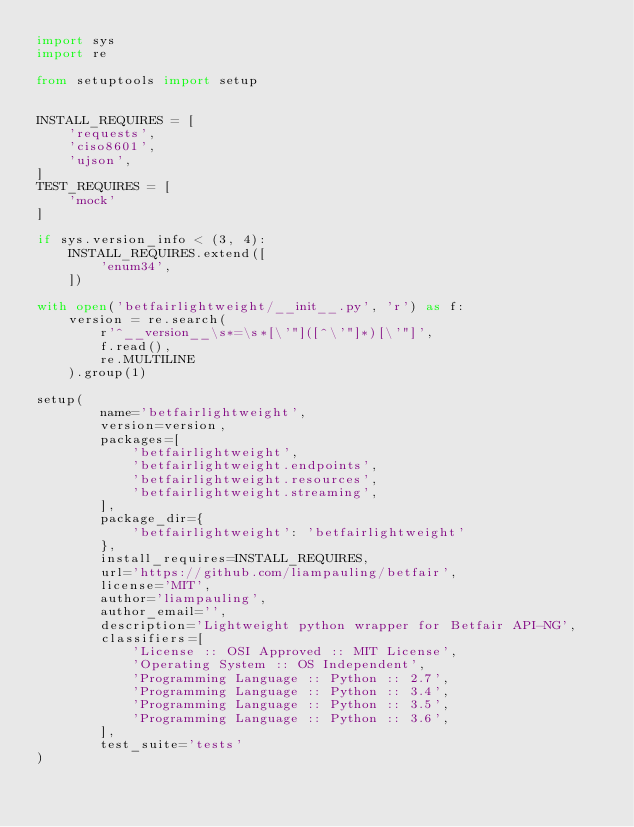Convert code to text. <code><loc_0><loc_0><loc_500><loc_500><_Python_>import sys
import re

from setuptools import setup


INSTALL_REQUIRES = [
    'requests',
    'ciso8601',
    'ujson',
]
TEST_REQUIRES = [
    'mock'
]

if sys.version_info < (3, 4):
    INSTALL_REQUIRES.extend([
        'enum34',
    ])

with open('betfairlightweight/__init__.py', 'r') as f:
    version = re.search(
        r'^__version__\s*=\s*[\'"]([^\'"]*)[\'"]',
        f.read(),
        re.MULTILINE
    ).group(1)

setup(
        name='betfairlightweight',
        version=version,
        packages=[
            'betfairlightweight',
            'betfairlightweight.endpoints',
            'betfairlightweight.resources',
            'betfairlightweight.streaming',
        ],
        package_dir={
            'betfairlightweight': 'betfairlightweight'
        },
        install_requires=INSTALL_REQUIRES,
        url='https://github.com/liampauling/betfair',
        license='MIT',
        author='liampauling',
        author_email='',
        description='Lightweight python wrapper for Betfair API-NG',
        classifiers=[
            'License :: OSI Approved :: MIT License',
            'Operating System :: OS Independent',
            'Programming Language :: Python :: 2.7',
            'Programming Language :: Python :: 3.4',
            'Programming Language :: Python :: 3.5',
            'Programming Language :: Python :: 3.6',
        ],
        test_suite='tests'
)
</code> 